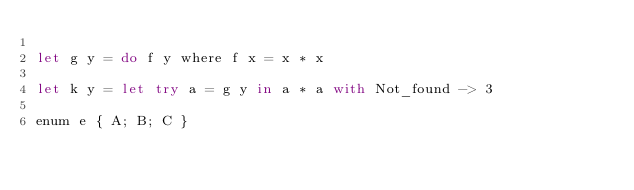Convert code to text. <code><loc_0><loc_0><loc_500><loc_500><_OCaml_>
let g y = do f y where f x = x * x

let k y = let try a = g y in a * a with Not_found -> 3

enum e { A; B; C }
</code> 